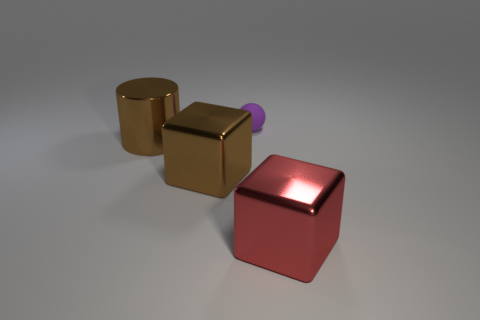Is there anything else that is the same size as the purple rubber object?
Provide a succinct answer. No. How many shiny things are on the left side of the big metal cube to the left of the tiny matte sphere?
Your response must be concise. 1. Are there any other things that are made of the same material as the brown cylinder?
Keep it short and to the point. Yes. How many things are either metal blocks that are left of the purple ball or small brown cylinders?
Ensure brevity in your answer.  1. How big is the cube on the right side of the purple ball?
Keep it short and to the point. Large. What material is the tiny thing?
Make the answer very short. Rubber. There is a large metal thing that is on the right side of the brown metal object that is in front of the large brown cylinder; what shape is it?
Provide a succinct answer. Cube. How many other objects are there of the same shape as the purple thing?
Keep it short and to the point. 0. There is a tiny sphere; are there any small matte objects in front of it?
Your response must be concise. No. The rubber thing is what color?
Provide a short and direct response. Purple. 